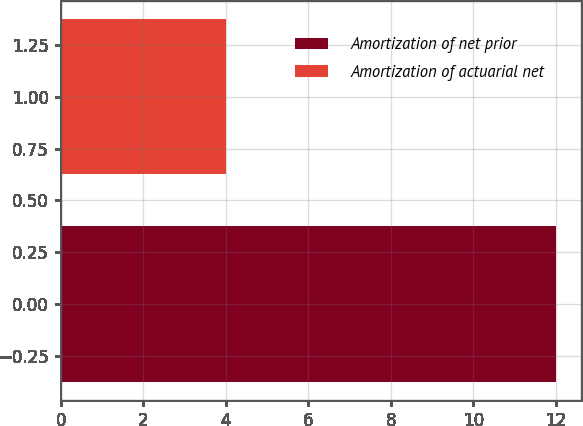Convert chart. <chart><loc_0><loc_0><loc_500><loc_500><bar_chart><fcel>Amortization of net prior<fcel>Amortization of actuarial net<nl><fcel>12<fcel>4<nl></chart> 